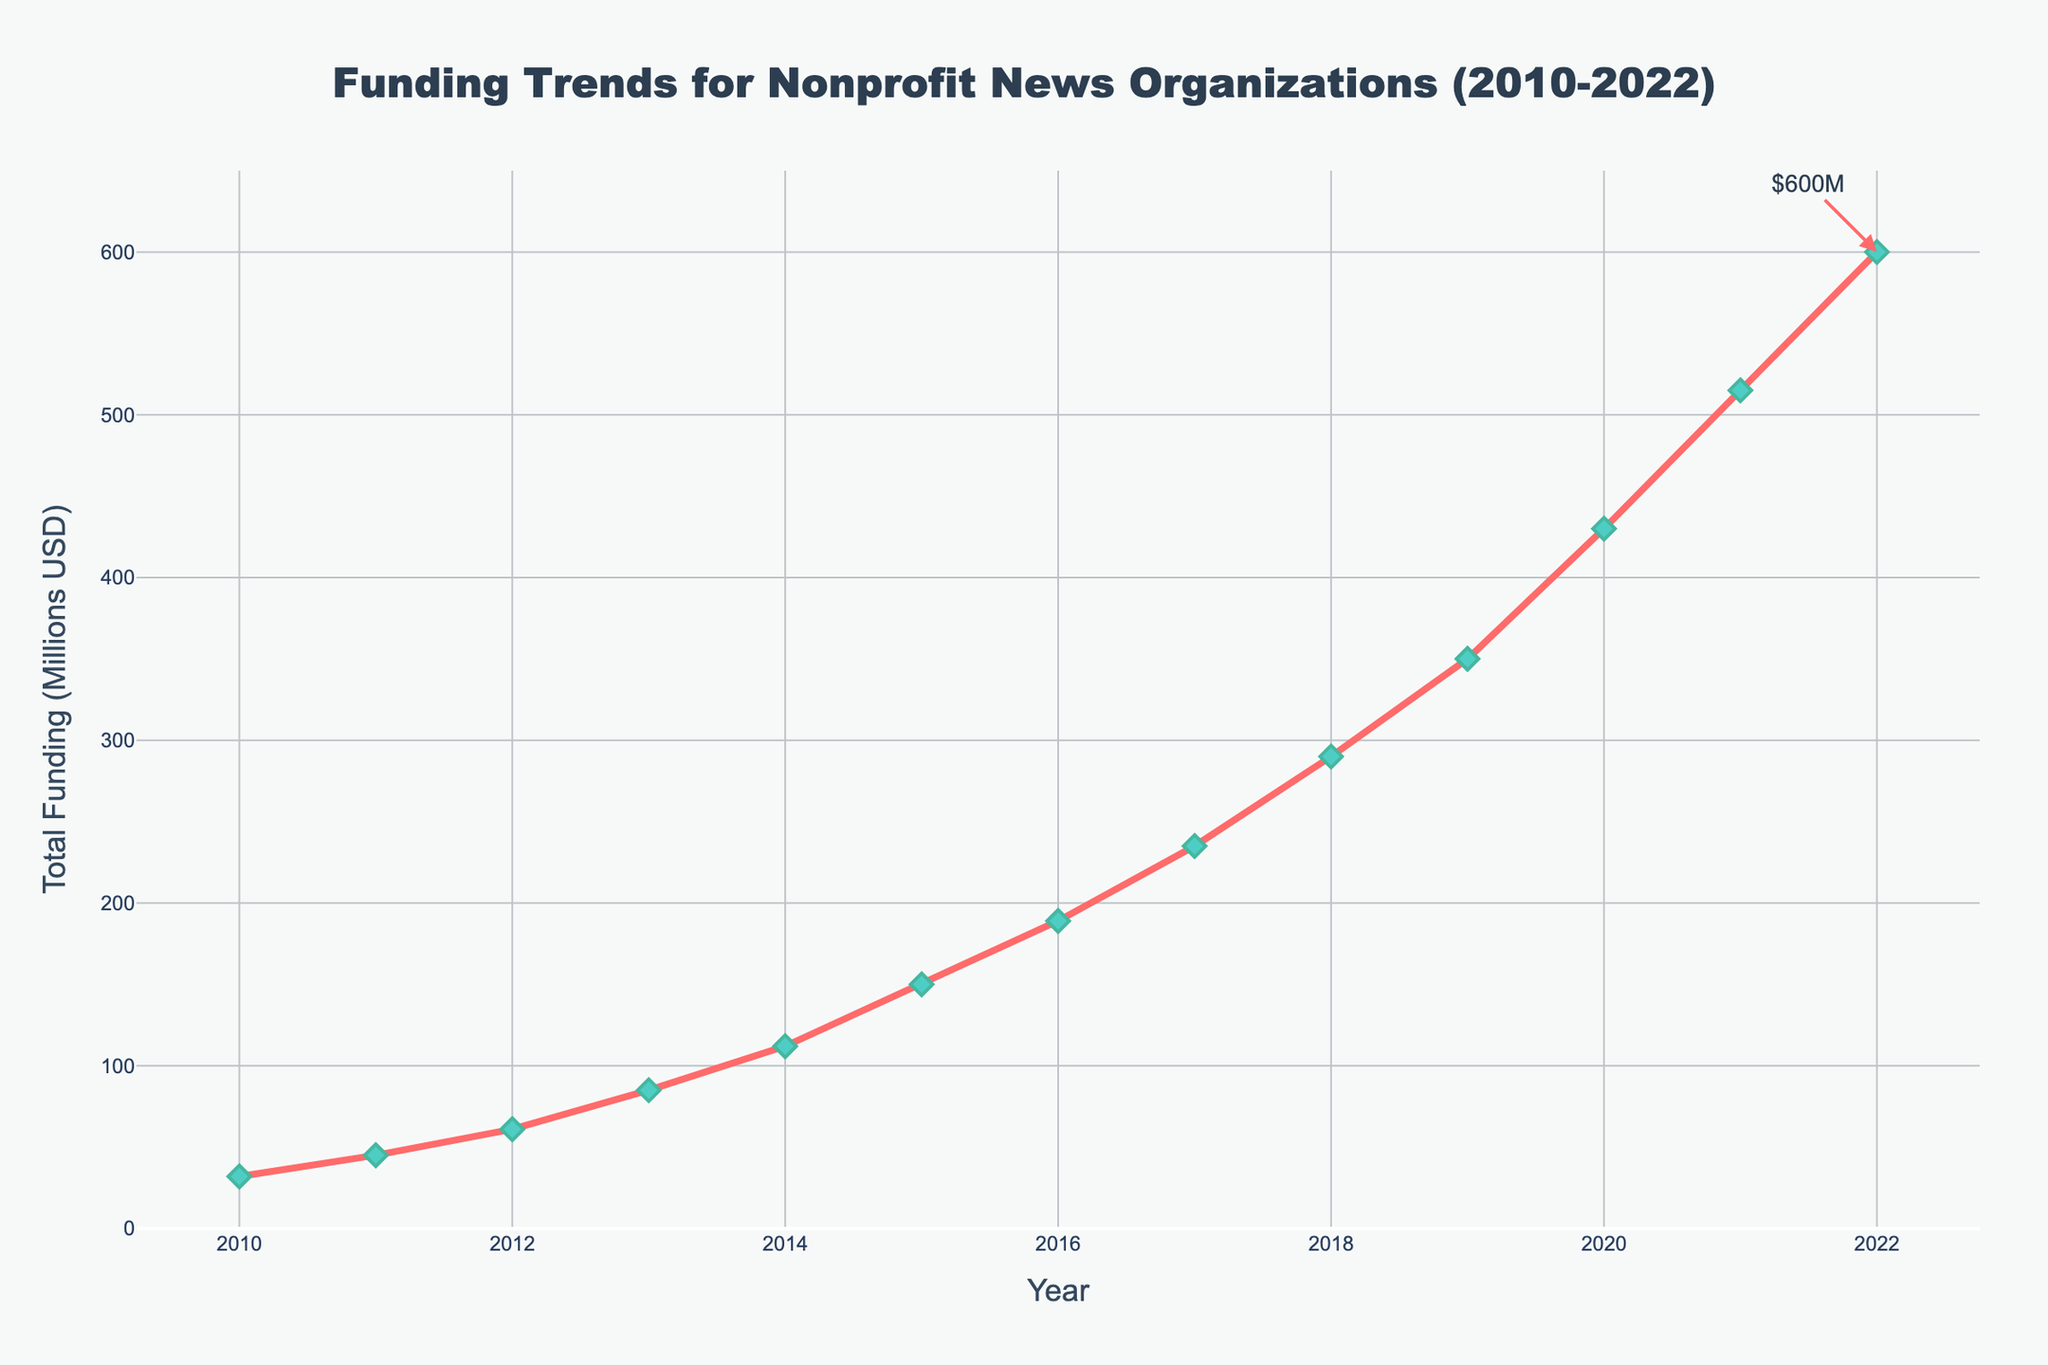How much more funding was there in 2020 compared to 2010? First, find the funding for 2020, which is $430M. Then, find the funding for 2010, which is $32M. Subtract the 2010 funding from the 2020 funding: $430M - $32M = $398M.
Answer: $398M What was the average annual funding between 2015 and 2020? Find the funding for each year from 2015 to 2020: $150M (2015), $189M (2016), $235M (2017), $290M (2018), $350M (2019), $430M (2020). Sum these values: 150 + 189 + 235 + 290 + 350 + 430 = 1644. Divide by the number of years (6): 1644 / 6 = 274.
Answer: $274M In which year did the funding see the highest increase compared to the previous year? Calculate the year-over-year increases and compare them:
2011-2010: 45 - 32 = 13
2012-2011: 61 - 45 = 16
2013-2012: 85 - 61 = 24
2014-2013: 112 - 85 = 27
2015-2014: 150 - 112 = 38
2016-2015: 189 - 150 = 39
2017-2016: 235 - 189 = 46
2018-2017: 290 - 235 = 55
2019-2018: 350 - 290 = 60
2020-2019: 430 - 350 = 80
2021-2020: 515 - 430 = 85
2022-2021: 600 - 515 = 85
The highest increase was between 2021 and 2022 or 2020 and 2021, both being 85.
Answer: 2021 and 2022 By how much did the total funding increase between 2010 and 2015? Find the funding for 2010 ($32M) and for 2015 ($150M). Subtract the 2010 funding from the 2015 funding: 150 - 32 = 118.
Answer: $118M Which year had a funding of approximately $235M? Locate the data point closest to $235M, which is for the year 2017.
Answer: 2017 What is the visual characteristic of the markers on the line plot? The plot uses diamond-shaped markers, which are green with a dark green boundary and are relatively large in size.
Answer: Green diamonds Is the funding trend generally increasing or decreasing from 2010 to 2022? Observe the general direction of the line from 2010 to 2022, which shows a steady increase every year.
Answer: Increasing What was the total funding in millions USD in 2014 and how was it indicated in the plot? From the data, the total funding in 2014 was $112M. It is indicated as a point on the line plot corresponding to the year 2014 on the x-axis and $112M on the y-axis.
Answer: $112M Calculate the total increase in funding from 2016 to 2018. Find the funding for 2016 ($189M) and for 2018 ($290M). Subtract the 2016 funding from the 2018 funding: 290 - 189 = 101.
Answer: $101M What is the value of the annotation text at the end of the plotted line? The annotation text at the end of the plotted line is "$600M."
Answer: $600M 